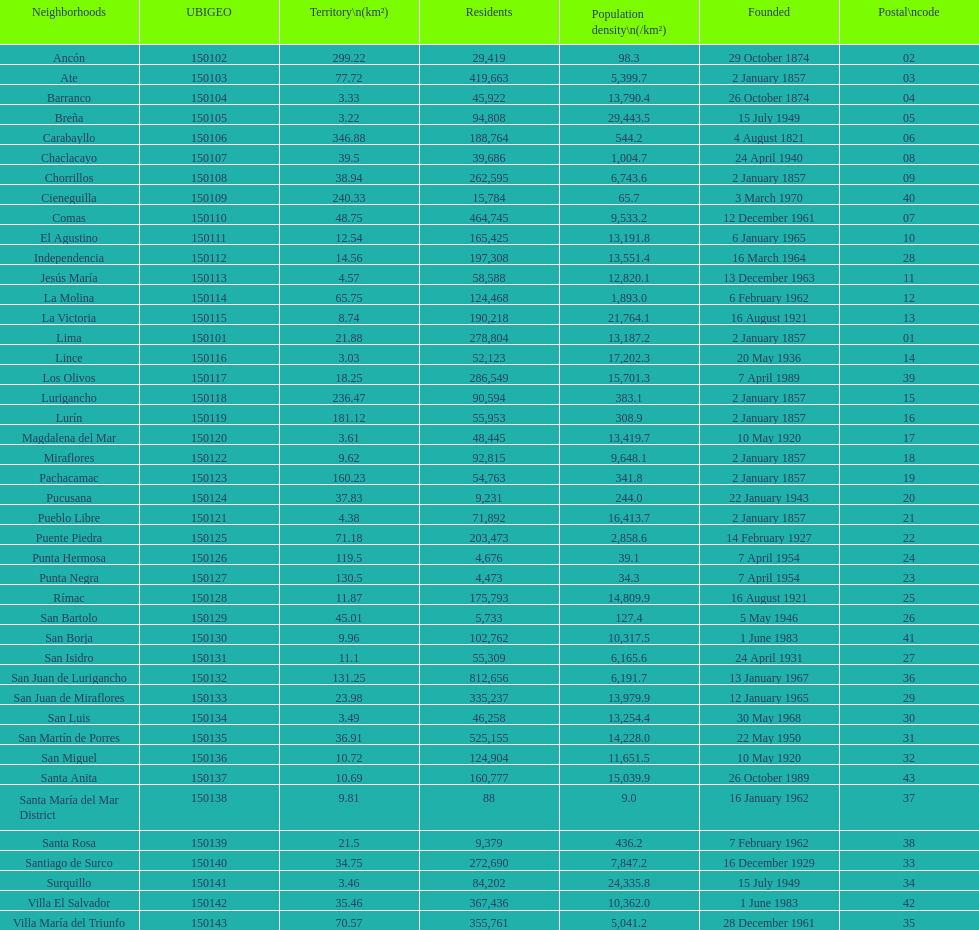What is the total number of districts of lima? 43. 